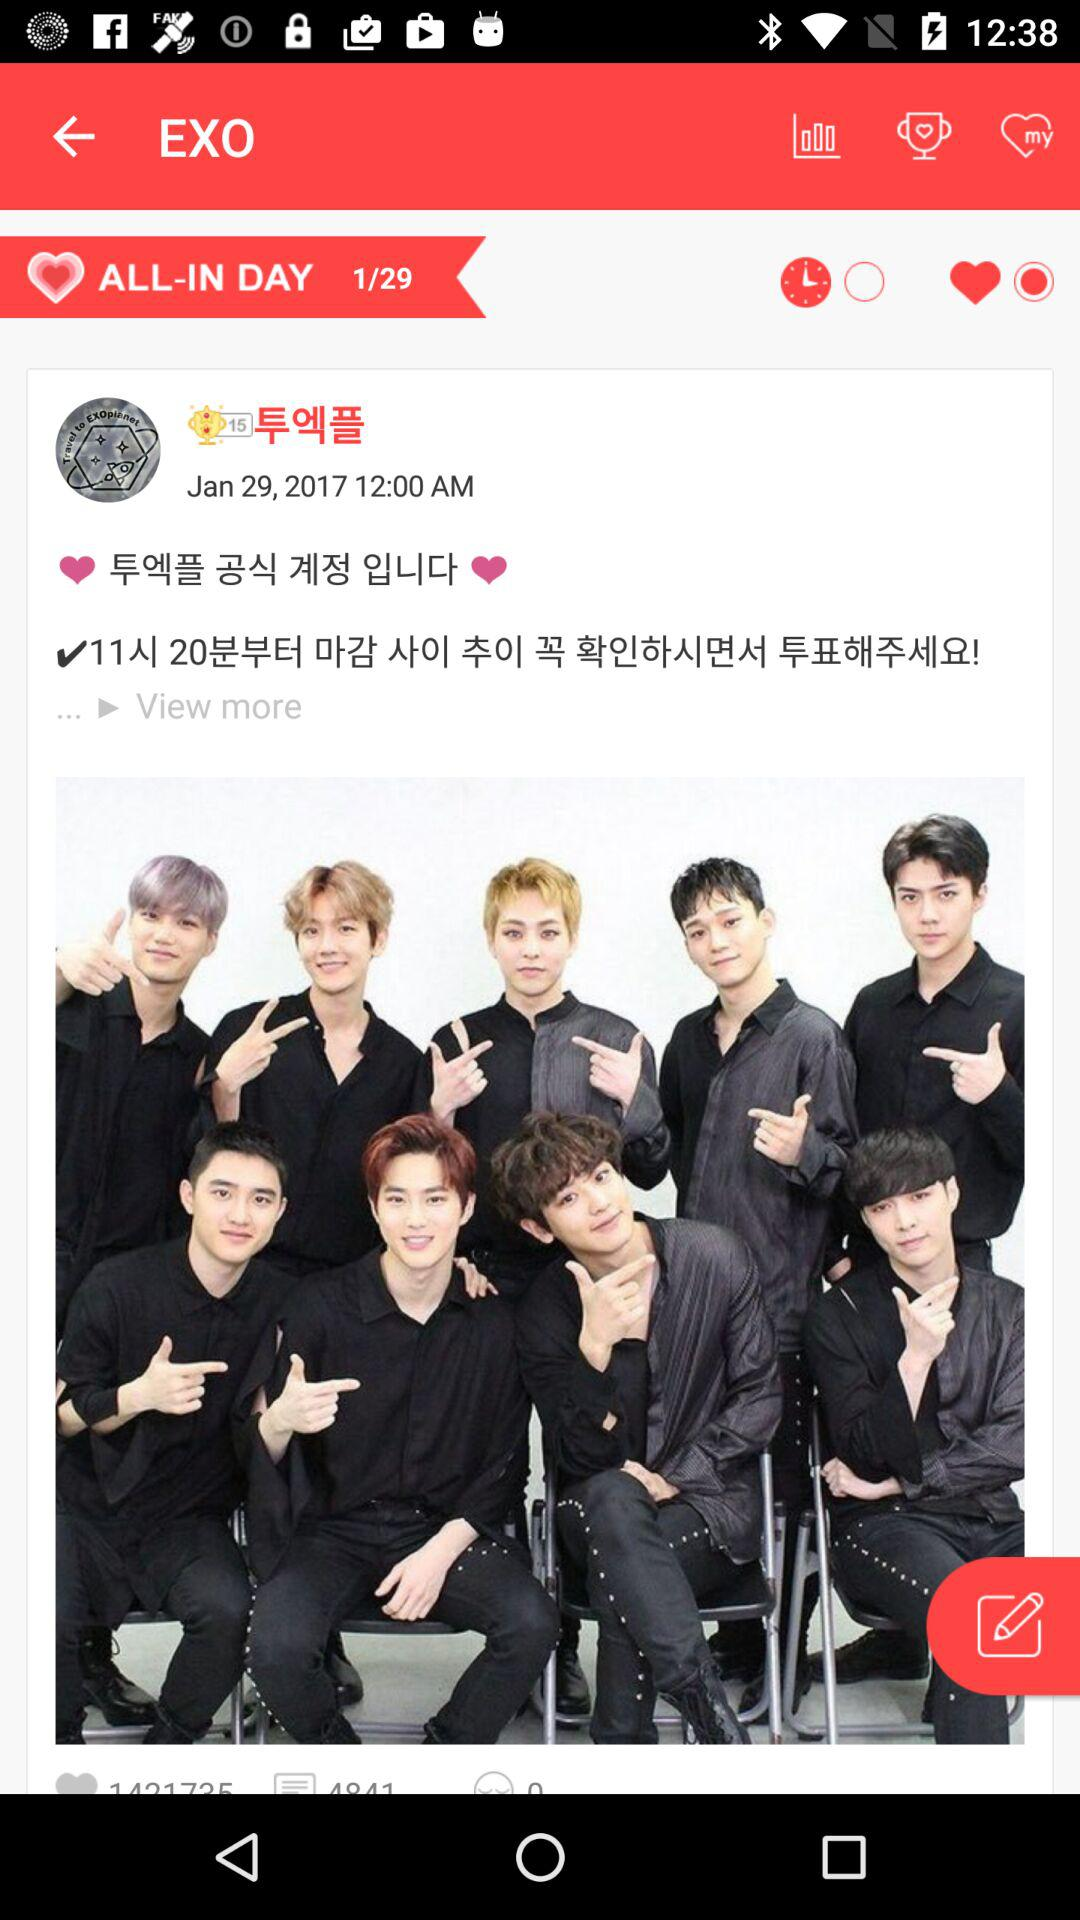How many total posts are there? There are 29 total posts. 